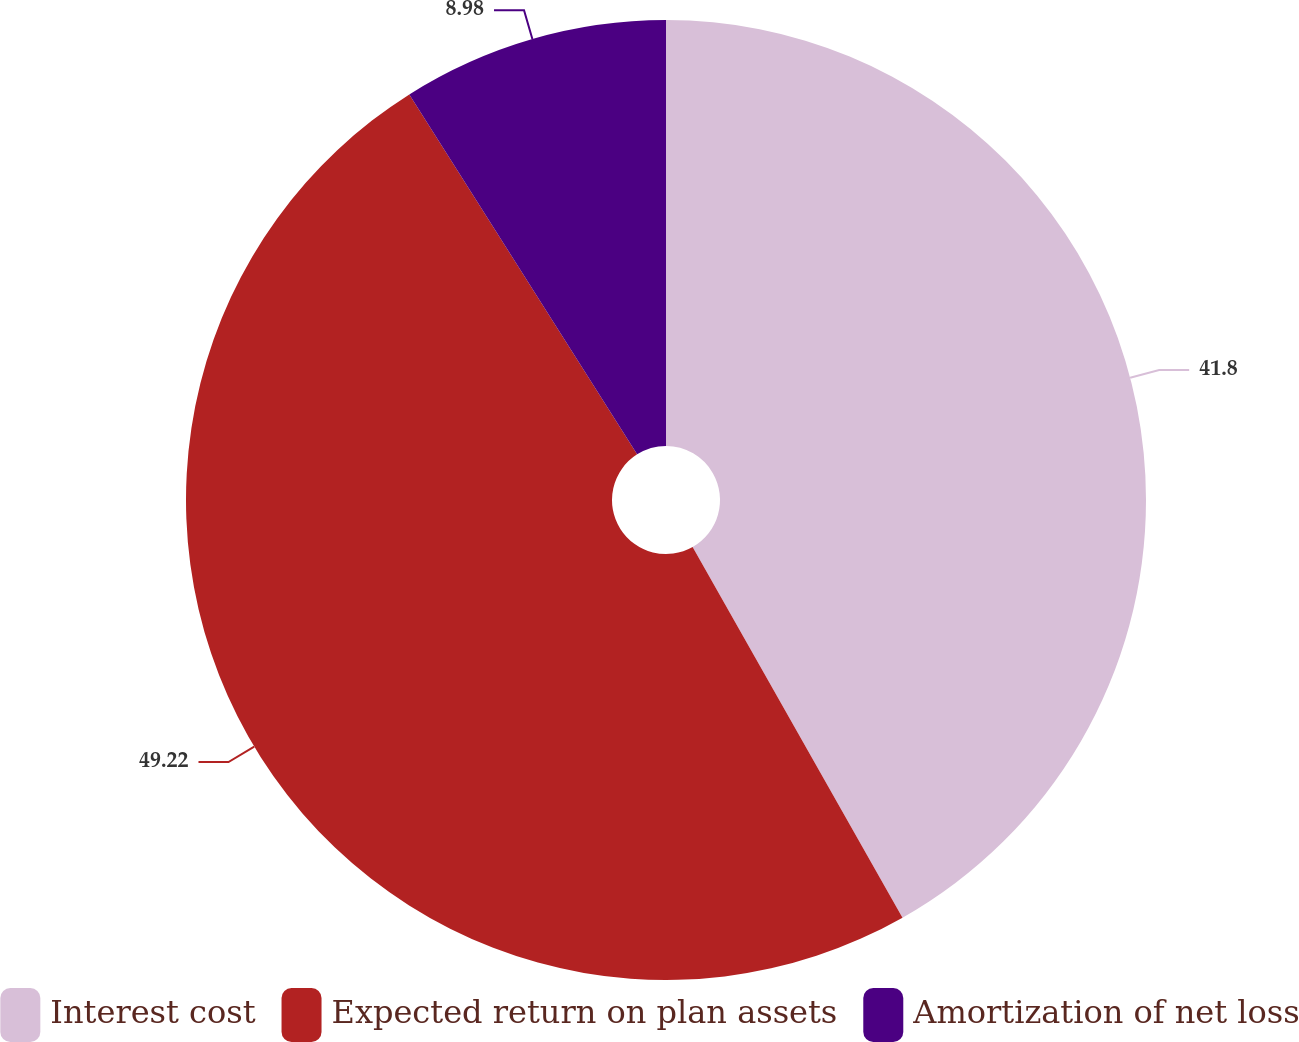Convert chart to OTSL. <chart><loc_0><loc_0><loc_500><loc_500><pie_chart><fcel>Interest cost<fcel>Expected return on plan assets<fcel>Amortization of net loss<nl><fcel>41.8%<fcel>49.22%<fcel>8.98%<nl></chart> 